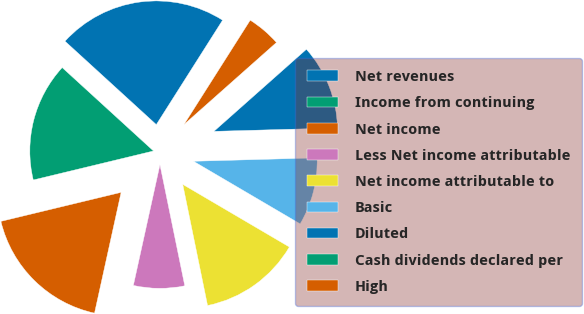Convert chart to OTSL. <chart><loc_0><loc_0><loc_500><loc_500><pie_chart><fcel>Net revenues<fcel>Income from continuing<fcel>Net income<fcel>Less Net income attributable<fcel>Net income attributable to<fcel>Basic<fcel>Diluted<fcel>Cash dividends declared per<fcel>High<nl><fcel>22.22%<fcel>15.55%<fcel>17.78%<fcel>6.67%<fcel>13.33%<fcel>8.89%<fcel>11.11%<fcel>0.0%<fcel>4.45%<nl></chart> 